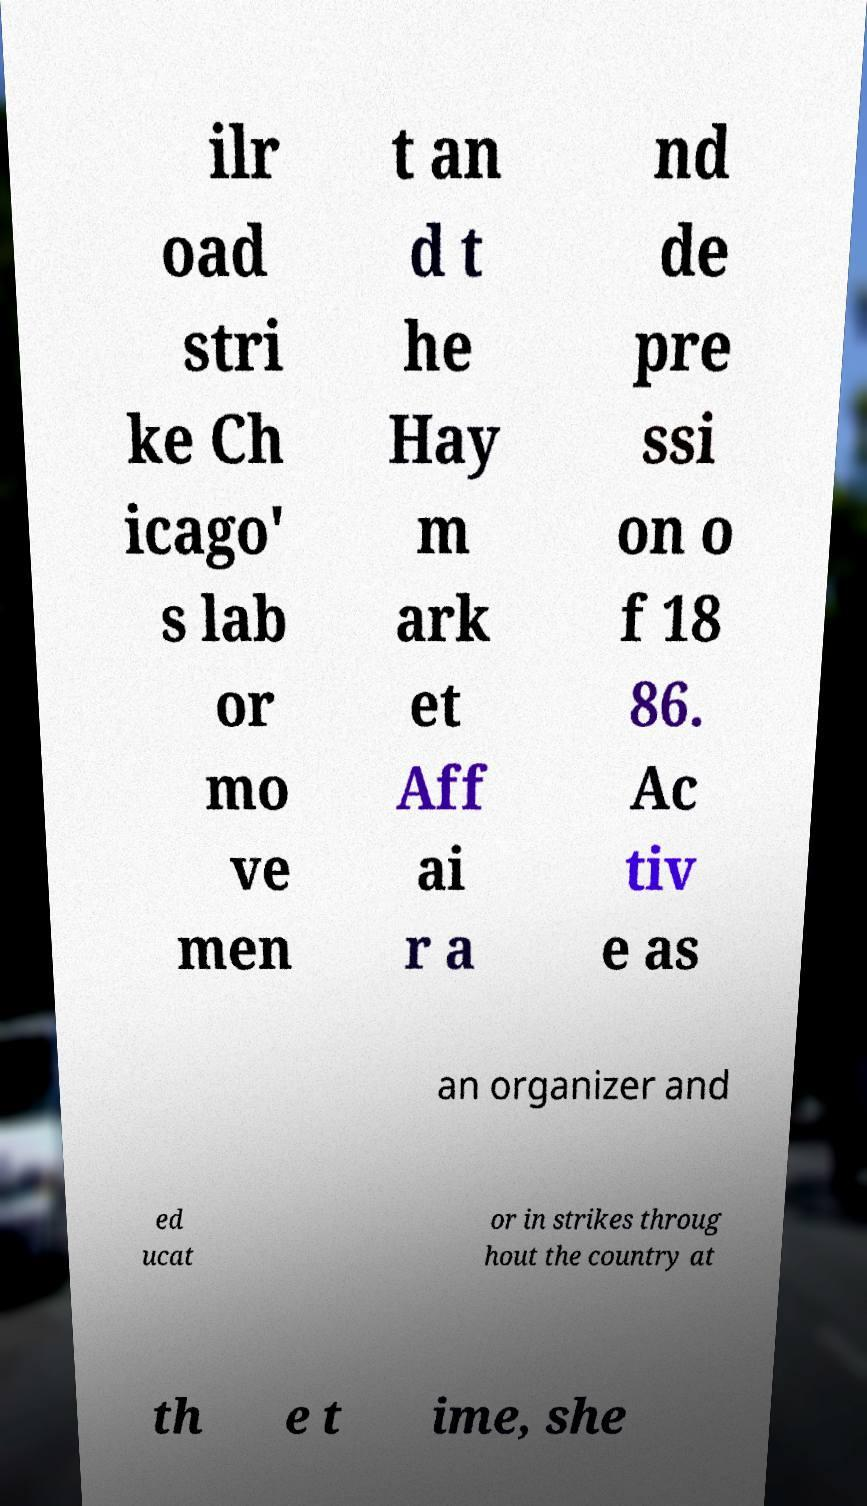There's text embedded in this image that I need extracted. Can you transcribe it verbatim? ilr oad stri ke Ch icago' s lab or mo ve men t an d t he Hay m ark et Aff ai r a nd de pre ssi on o f 18 86. Ac tiv e as an organizer and ed ucat or in strikes throug hout the country at th e t ime, she 